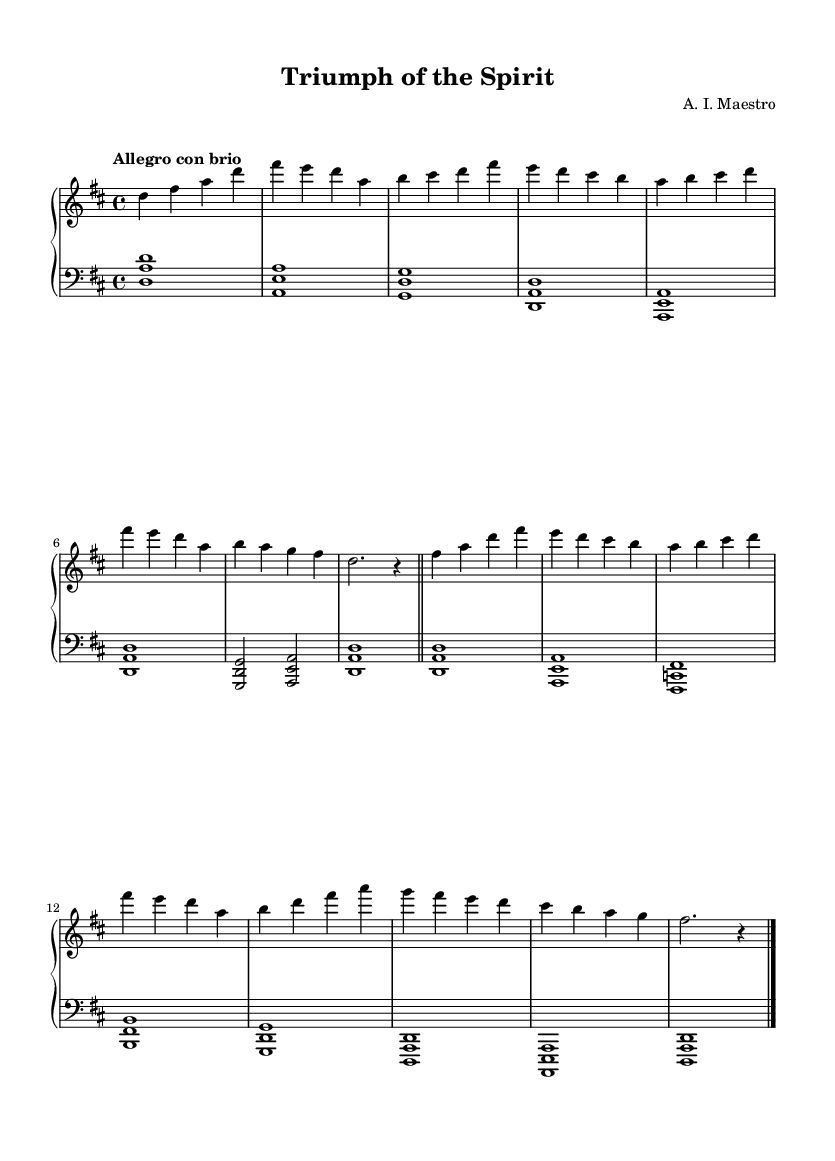What is the key signature of this music? The key signature is D major, which contains two sharps (F# and C#) indicated at the beginning of the staff.
Answer: D major What is the time signature of this music? The time signature is 4/4, which is indicated at the beginning of the piece by the "4/4" notation. This means there are four beats in each measure.
Answer: 4/4 What is the tempo marking for this piece? The tempo marking is "Allegro con brio," which suggests a fast and lively pace. This is indicated above the staff at the beginning of the music.
Answer: Allegro con brio How many measures are in the right hand part? The right hand part contains 8 measures, as counted by looking at the repeated bar lines and the total number of measures specified.
Answer: 8 What types of chords are predominantly used in the left hand? The left hand predominantly uses triadic chords, often played in root position. This can be discerned by looking at the structure of the notes played together within each measure.
Answer: Triadic chords What is the final dynamic marking indicated in the music? The final dynamic marking is "r," which indicates a rest, typically signaling the end of a phrase or piece. This can be seen at the end of the last bar.
Answer: r What is the overall mood conveyed by this piece? The overall mood is triumphant and determined, as suggested by the title "Triumph of the Spirit" and the upbeat tempo and strong dynamics throughout.
Answer: Triumphant 